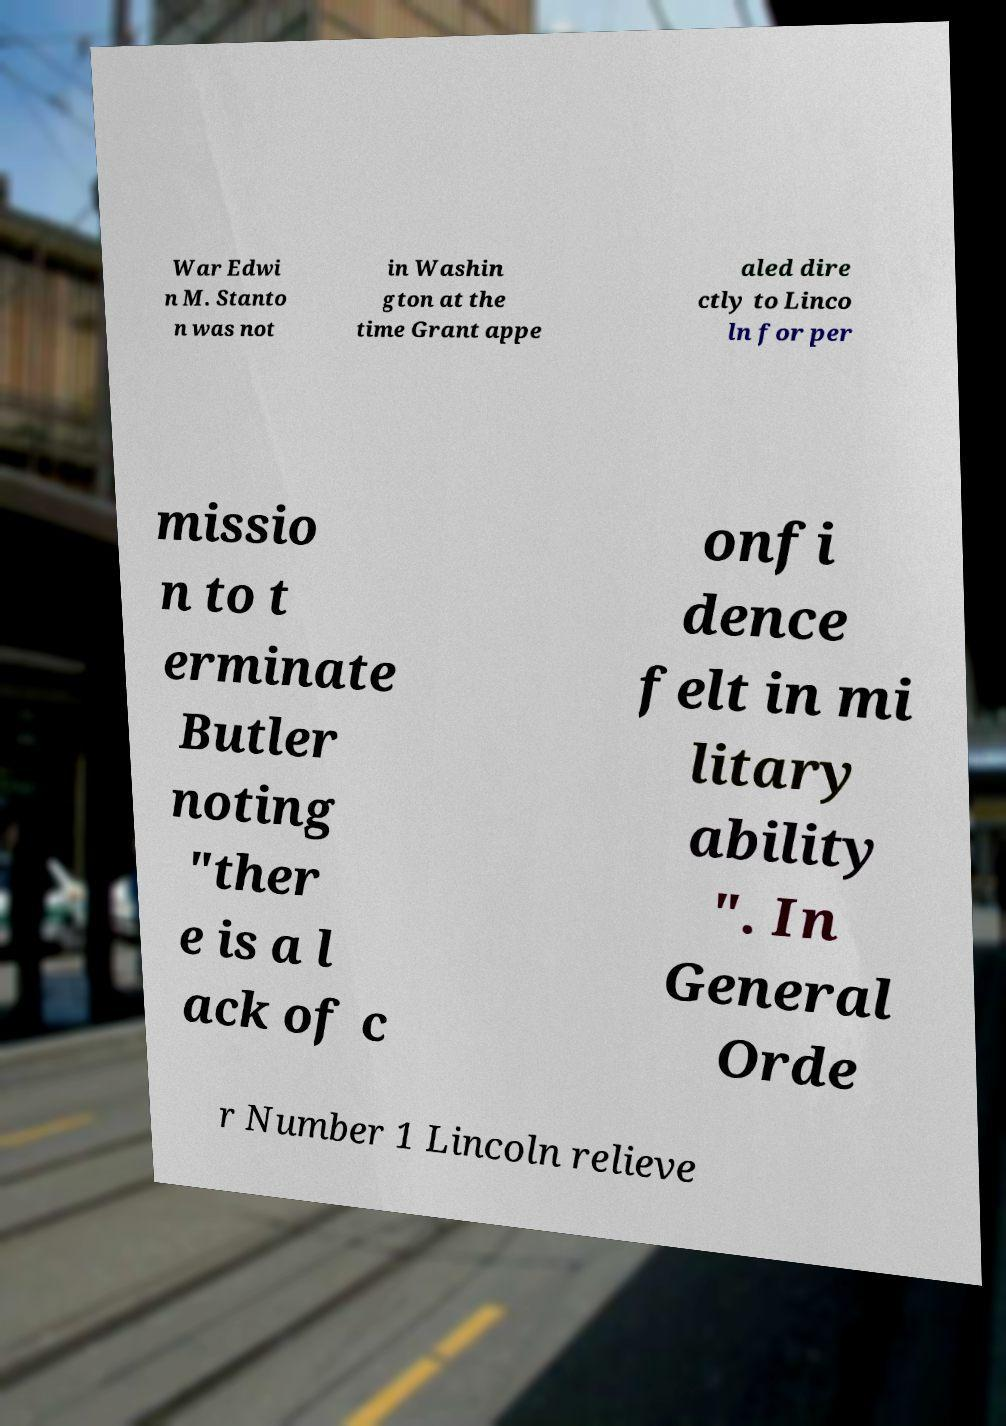Could you assist in decoding the text presented in this image and type it out clearly? War Edwi n M. Stanto n was not in Washin gton at the time Grant appe aled dire ctly to Linco ln for per missio n to t erminate Butler noting "ther e is a l ack of c onfi dence felt in mi litary ability ". In General Orde r Number 1 Lincoln relieve 